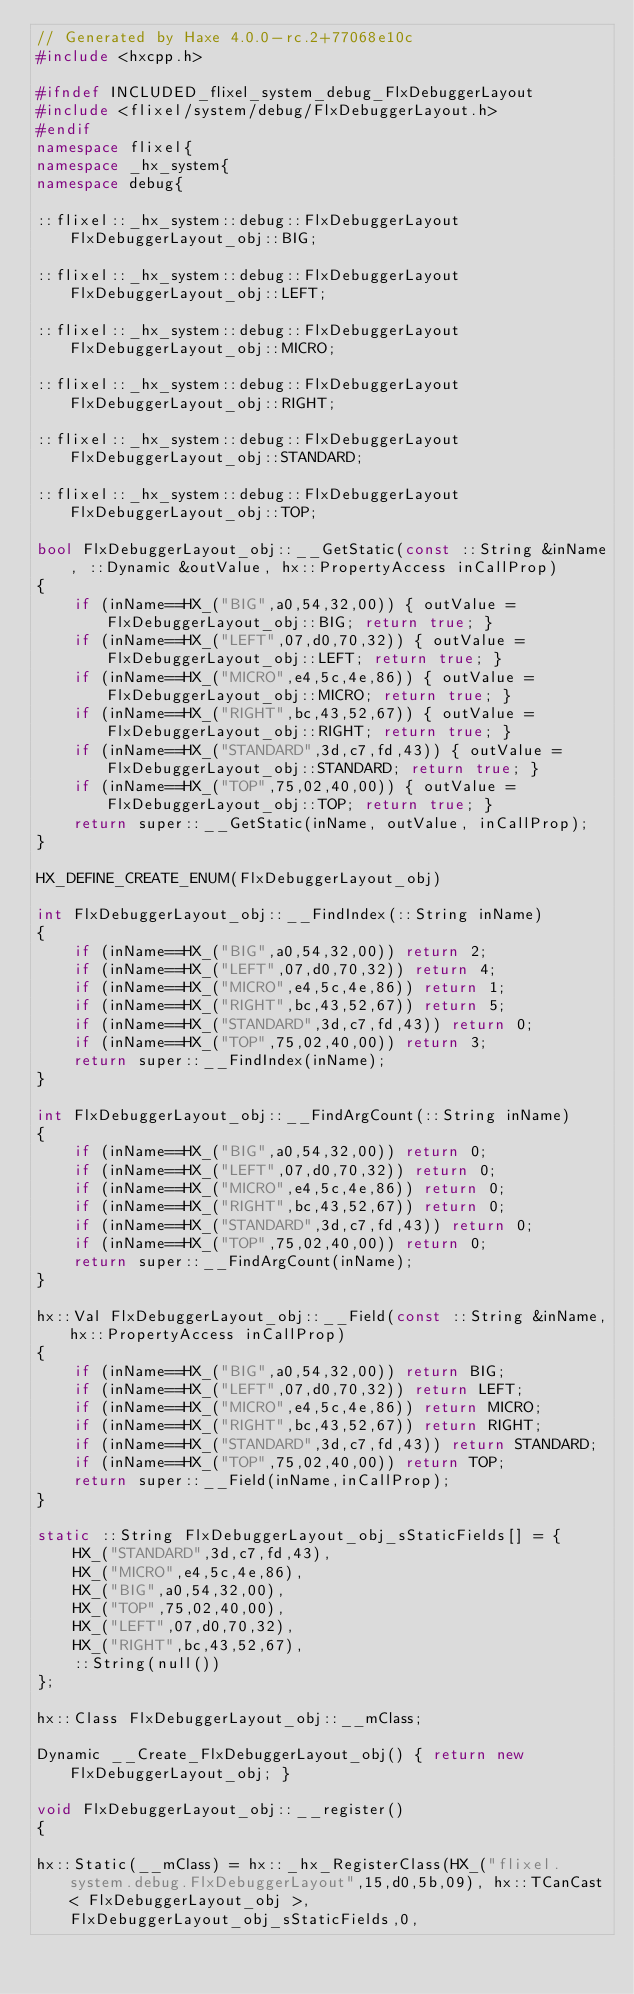Convert code to text. <code><loc_0><loc_0><loc_500><loc_500><_C++_>// Generated by Haxe 4.0.0-rc.2+77068e10c
#include <hxcpp.h>

#ifndef INCLUDED_flixel_system_debug_FlxDebuggerLayout
#include <flixel/system/debug/FlxDebuggerLayout.h>
#endif
namespace flixel{
namespace _hx_system{
namespace debug{

::flixel::_hx_system::debug::FlxDebuggerLayout FlxDebuggerLayout_obj::BIG;

::flixel::_hx_system::debug::FlxDebuggerLayout FlxDebuggerLayout_obj::LEFT;

::flixel::_hx_system::debug::FlxDebuggerLayout FlxDebuggerLayout_obj::MICRO;

::flixel::_hx_system::debug::FlxDebuggerLayout FlxDebuggerLayout_obj::RIGHT;

::flixel::_hx_system::debug::FlxDebuggerLayout FlxDebuggerLayout_obj::STANDARD;

::flixel::_hx_system::debug::FlxDebuggerLayout FlxDebuggerLayout_obj::TOP;

bool FlxDebuggerLayout_obj::__GetStatic(const ::String &inName, ::Dynamic &outValue, hx::PropertyAccess inCallProp)
{
	if (inName==HX_("BIG",a0,54,32,00)) { outValue = FlxDebuggerLayout_obj::BIG; return true; }
	if (inName==HX_("LEFT",07,d0,70,32)) { outValue = FlxDebuggerLayout_obj::LEFT; return true; }
	if (inName==HX_("MICRO",e4,5c,4e,86)) { outValue = FlxDebuggerLayout_obj::MICRO; return true; }
	if (inName==HX_("RIGHT",bc,43,52,67)) { outValue = FlxDebuggerLayout_obj::RIGHT; return true; }
	if (inName==HX_("STANDARD",3d,c7,fd,43)) { outValue = FlxDebuggerLayout_obj::STANDARD; return true; }
	if (inName==HX_("TOP",75,02,40,00)) { outValue = FlxDebuggerLayout_obj::TOP; return true; }
	return super::__GetStatic(inName, outValue, inCallProp);
}

HX_DEFINE_CREATE_ENUM(FlxDebuggerLayout_obj)

int FlxDebuggerLayout_obj::__FindIndex(::String inName)
{
	if (inName==HX_("BIG",a0,54,32,00)) return 2;
	if (inName==HX_("LEFT",07,d0,70,32)) return 4;
	if (inName==HX_("MICRO",e4,5c,4e,86)) return 1;
	if (inName==HX_("RIGHT",bc,43,52,67)) return 5;
	if (inName==HX_("STANDARD",3d,c7,fd,43)) return 0;
	if (inName==HX_("TOP",75,02,40,00)) return 3;
	return super::__FindIndex(inName);
}

int FlxDebuggerLayout_obj::__FindArgCount(::String inName)
{
	if (inName==HX_("BIG",a0,54,32,00)) return 0;
	if (inName==HX_("LEFT",07,d0,70,32)) return 0;
	if (inName==HX_("MICRO",e4,5c,4e,86)) return 0;
	if (inName==HX_("RIGHT",bc,43,52,67)) return 0;
	if (inName==HX_("STANDARD",3d,c7,fd,43)) return 0;
	if (inName==HX_("TOP",75,02,40,00)) return 0;
	return super::__FindArgCount(inName);
}

hx::Val FlxDebuggerLayout_obj::__Field(const ::String &inName,hx::PropertyAccess inCallProp)
{
	if (inName==HX_("BIG",a0,54,32,00)) return BIG;
	if (inName==HX_("LEFT",07,d0,70,32)) return LEFT;
	if (inName==HX_("MICRO",e4,5c,4e,86)) return MICRO;
	if (inName==HX_("RIGHT",bc,43,52,67)) return RIGHT;
	if (inName==HX_("STANDARD",3d,c7,fd,43)) return STANDARD;
	if (inName==HX_("TOP",75,02,40,00)) return TOP;
	return super::__Field(inName,inCallProp);
}

static ::String FlxDebuggerLayout_obj_sStaticFields[] = {
	HX_("STANDARD",3d,c7,fd,43),
	HX_("MICRO",e4,5c,4e,86),
	HX_("BIG",a0,54,32,00),
	HX_("TOP",75,02,40,00),
	HX_("LEFT",07,d0,70,32),
	HX_("RIGHT",bc,43,52,67),
	::String(null())
};

hx::Class FlxDebuggerLayout_obj::__mClass;

Dynamic __Create_FlxDebuggerLayout_obj() { return new FlxDebuggerLayout_obj; }

void FlxDebuggerLayout_obj::__register()
{

hx::Static(__mClass) = hx::_hx_RegisterClass(HX_("flixel.system.debug.FlxDebuggerLayout",15,d0,5b,09), hx::TCanCast< FlxDebuggerLayout_obj >,FlxDebuggerLayout_obj_sStaticFields,0,</code> 